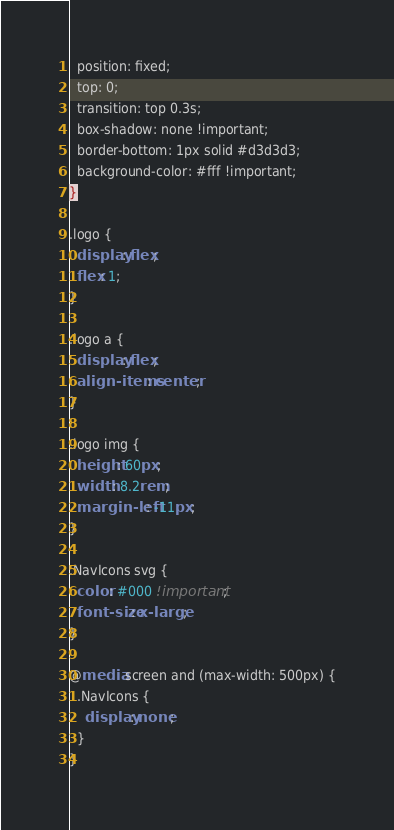Convert code to text. <code><loc_0><loc_0><loc_500><loc_500><_CSS_>  position: fixed;
  top: 0;
  transition: top 0.3s;
  box-shadow: none !important;
  border-bottom: 1px solid #d3d3d3;
  background-color: #fff !important;
}

.logo {
  display: flex;
  flex: 1;
}

.logo a {
  display: flex;
  align-items: center;
}

.logo img {
  height: 60px;
  width: 8.2rem;
  margin-left: -11px;
}

.NavIcons svg {
  color: #000 !important;
  font-size: x-large;
}

@media screen and (max-width: 500px) {
  .NavIcons {
    display: none;
  }
}
</code> 